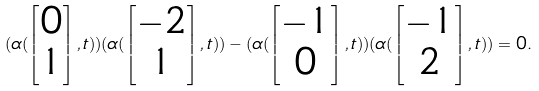<formula> <loc_0><loc_0><loc_500><loc_500>( \alpha ( \begin{bmatrix} 0 \\ 1 \end{bmatrix} , t ) ) ( \alpha ( \begin{bmatrix} - 2 \\ 1 \end{bmatrix} , t ) ) - ( \alpha ( \begin{bmatrix} - 1 \\ 0 \end{bmatrix} , t ) ) ( \alpha ( \begin{bmatrix} - 1 \\ 2 \end{bmatrix} , t ) ) = 0 .</formula> 